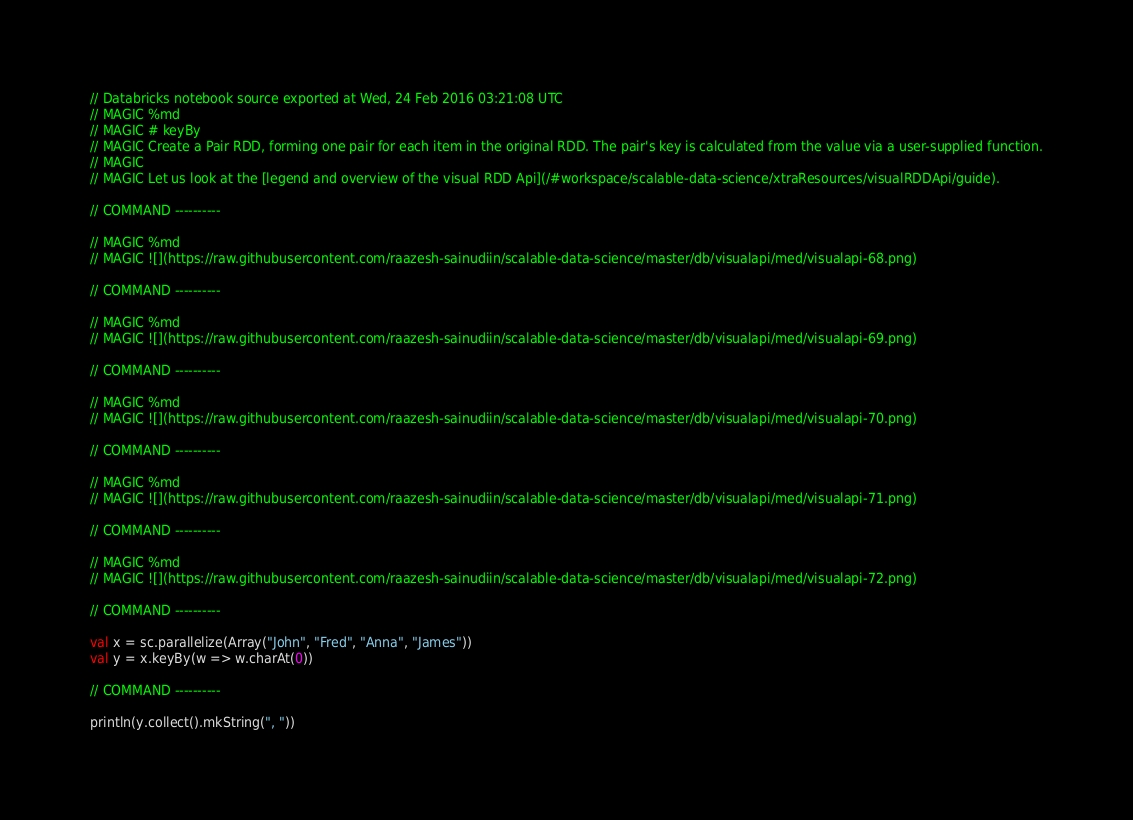Convert code to text. <code><loc_0><loc_0><loc_500><loc_500><_Scala_>// Databricks notebook source exported at Wed, 24 Feb 2016 03:21:08 UTC
// MAGIC %md
// MAGIC # keyBy
// MAGIC Create a Pair RDD, forming one pair for each item in the original RDD. The pair's key is calculated from the value via a user-supplied function.
// MAGIC 
// MAGIC Let us look at the [legend and overview of the visual RDD Api](/#workspace/scalable-data-science/xtraResources/visualRDDApi/guide).

// COMMAND ----------

// MAGIC %md
// MAGIC ![](https://raw.githubusercontent.com/raazesh-sainudiin/scalable-data-science/master/db/visualapi/med/visualapi-68.png)

// COMMAND ----------

// MAGIC %md
// MAGIC ![](https://raw.githubusercontent.com/raazesh-sainudiin/scalable-data-science/master/db/visualapi/med/visualapi-69.png)

// COMMAND ----------

// MAGIC %md
// MAGIC ![](https://raw.githubusercontent.com/raazesh-sainudiin/scalable-data-science/master/db/visualapi/med/visualapi-70.png)

// COMMAND ----------

// MAGIC %md
// MAGIC ![](https://raw.githubusercontent.com/raazesh-sainudiin/scalable-data-science/master/db/visualapi/med/visualapi-71.png)

// COMMAND ----------

// MAGIC %md
// MAGIC ![](https://raw.githubusercontent.com/raazesh-sainudiin/scalable-data-science/master/db/visualapi/med/visualapi-72.png)

// COMMAND ----------

val x = sc.parallelize(Array("John", "Fred", "Anna", "James"))
val y = x.keyBy(w => w.charAt(0))

// COMMAND ----------

println(y.collect().mkString(", "))</code> 